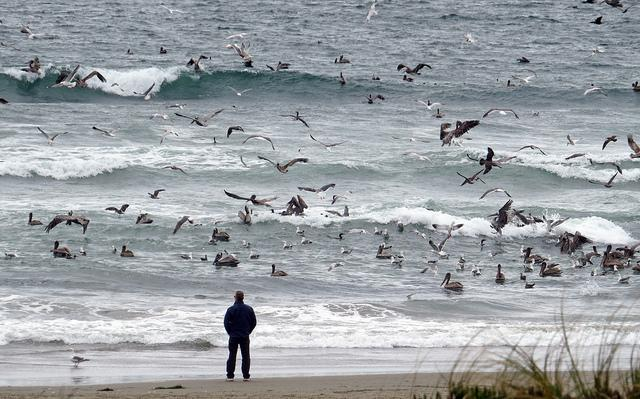What type of body of water are all of the birds gathering at? Please explain your reasoning. sea. The shore looks like that of the sea. 